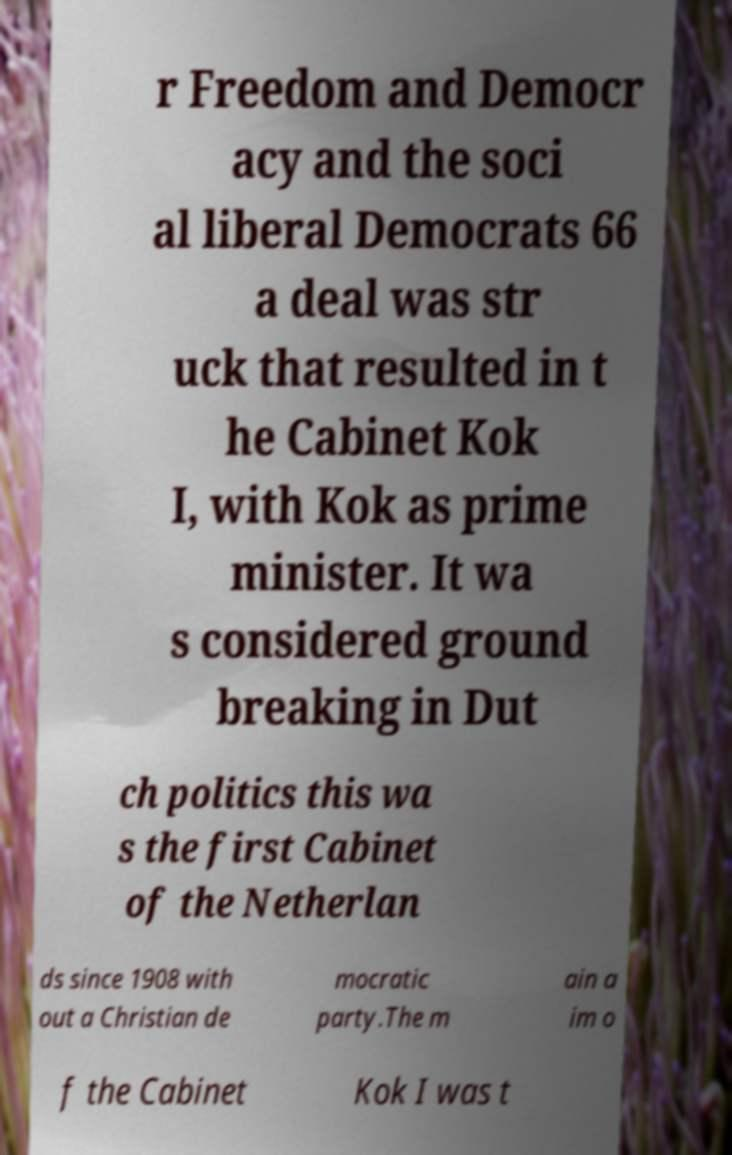Can you read and provide the text displayed in the image?This photo seems to have some interesting text. Can you extract and type it out for me? r Freedom and Democr acy and the soci al liberal Democrats 66 a deal was str uck that resulted in t he Cabinet Kok I, with Kok as prime minister. It wa s considered ground breaking in Dut ch politics this wa s the first Cabinet of the Netherlan ds since 1908 with out a Christian de mocratic party.The m ain a im o f the Cabinet Kok I was t 